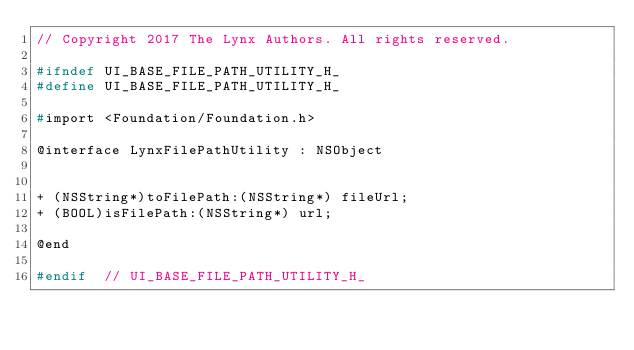Convert code to text. <code><loc_0><loc_0><loc_500><loc_500><_C_>// Copyright 2017 The Lynx Authors. All rights reserved.

#ifndef UI_BASE_FILE_PATH_UTILITY_H_
#define UI_BASE_FILE_PATH_UTILITY_H_

#import <Foundation/Foundation.h>

@interface LynxFilePathUtility : NSObject


+ (NSString*)toFilePath:(NSString*) fileUrl;
+ (BOOL)isFilePath:(NSString*) url;

@end

#endif  // UI_BASE_FILE_PATH_UTILITY_H_
</code> 